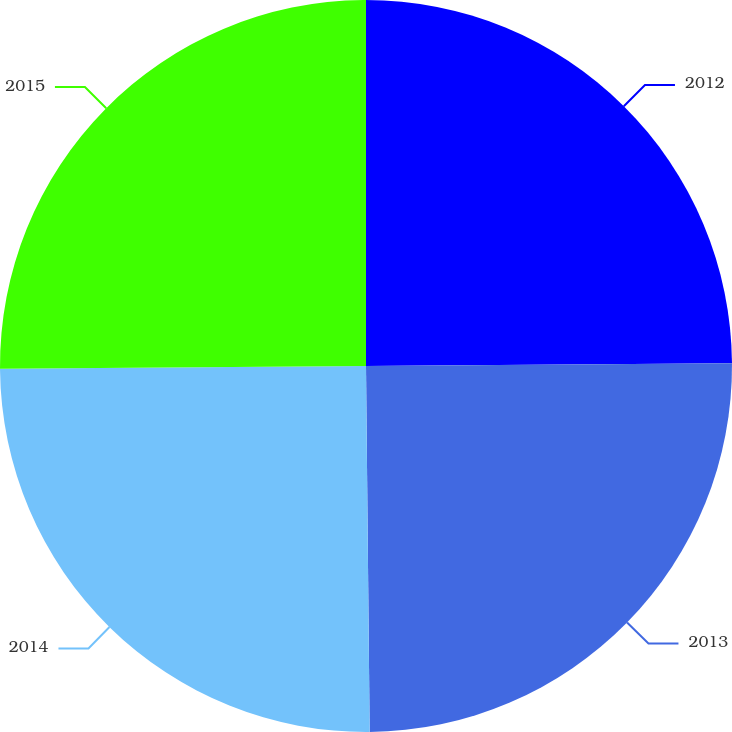Convert chart. <chart><loc_0><loc_0><loc_500><loc_500><pie_chart><fcel>2012<fcel>2013<fcel>2014<fcel>2015<nl><fcel>24.88%<fcel>24.96%<fcel>25.04%<fcel>25.12%<nl></chart> 